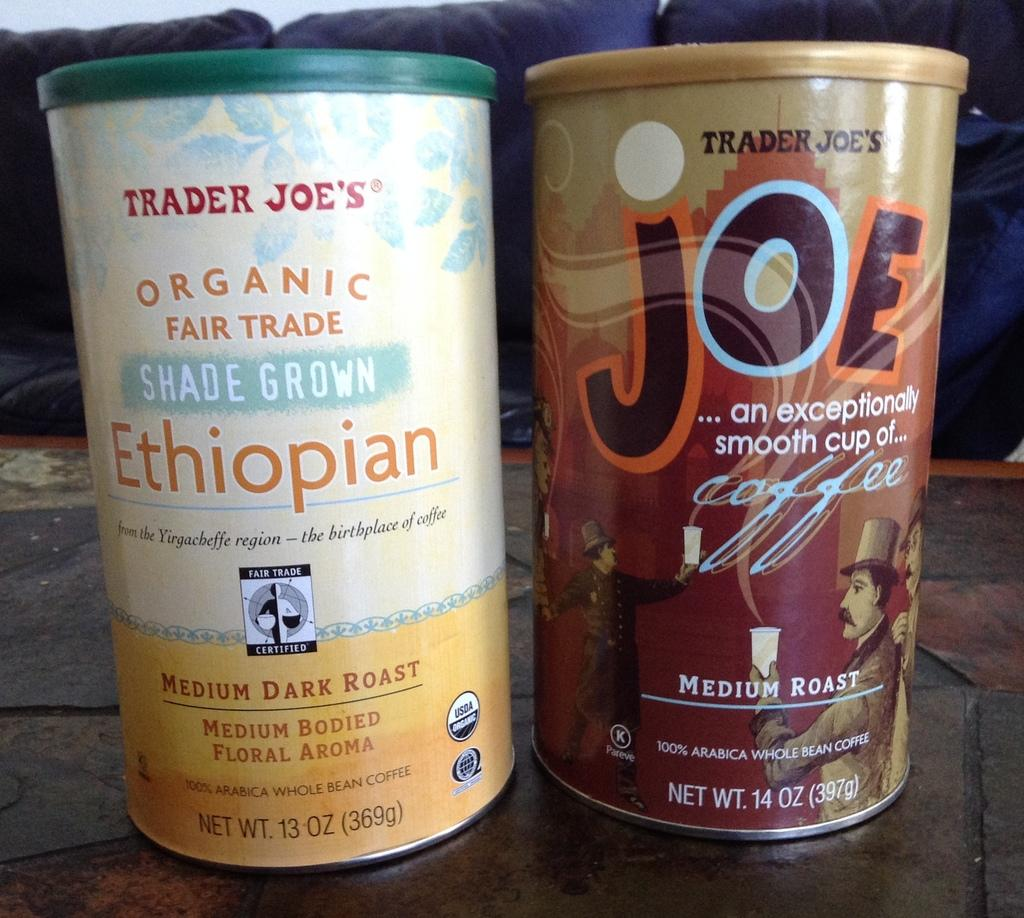<image>
Relay a brief, clear account of the picture shown. two Trader Joe's coffee products, one is Organic Fair Trade worthy.. 